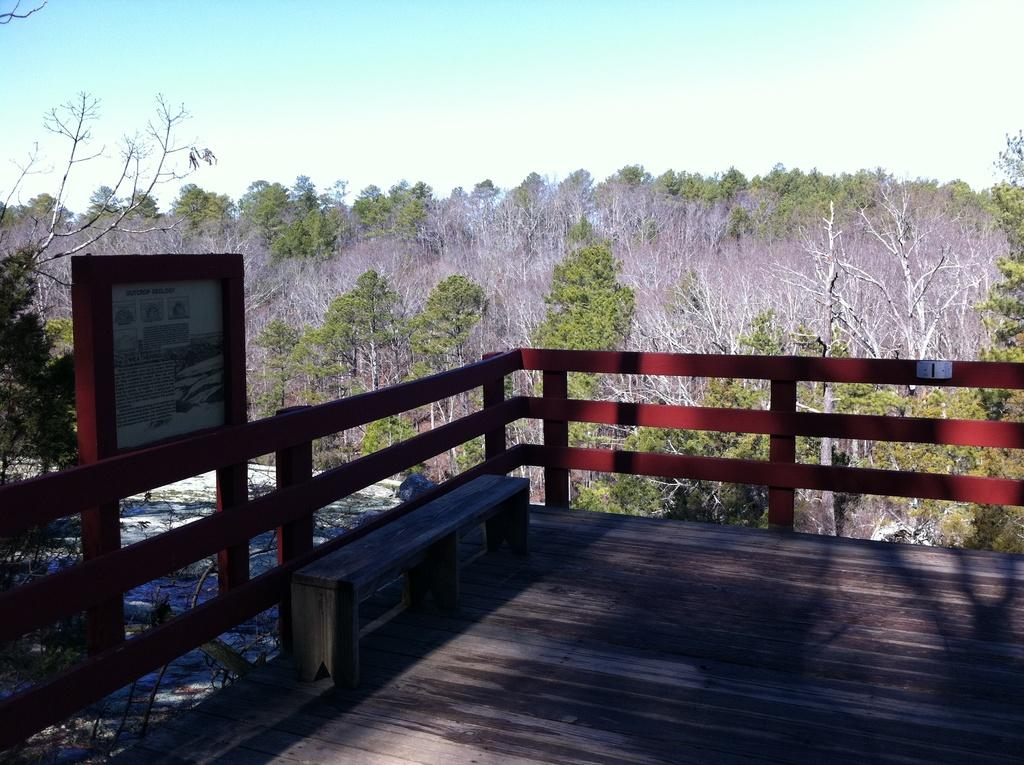What type of seating is visible in the image? There is a bench in the image. What type of barrier is present in the image? There is a fence in the image. What material is the surface on the left side of the image made of? There is a wooden surface in the image. What is on the left side of the image? There is a board on the left side of the image. What can be seen in the background of the image? There are trees and the sky visible in the background of the image. What type of polish is being applied to the board in the image? There is no indication of any polish being applied to the board in the image. In which direction is the bench facing in the image? The direction the bench is facing cannot be determined from the image alone. 